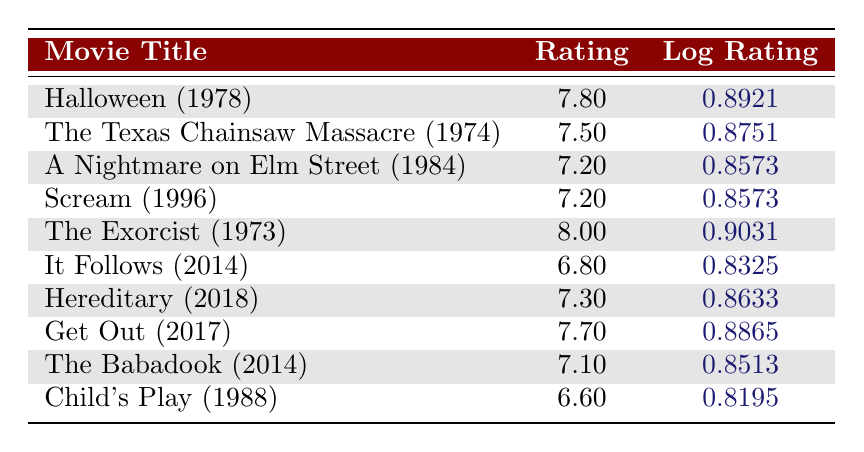What is the highest rating among the horror movies listed? The table lists the ratings, and upon inspection, the highest rating is 8.0 for "The Exorcist (1973)."
Answer: 8.0 Which horror movie has the lowest logarithmic rating in the table? Looking at the "Log Rating" column, "Child's Play (1988)" has the lowest logarithmic value of approximately 0.8195.
Answer: 0.8195 Is "Get Out (2017)" rated higher than "Hereditary (2018)"? "Get Out (2017)" has a rating of 7.7, while "Hereditary (2018)" has a rating of 7.3. Since 7.7 is greater than 7.3, "Get Out (2017)" is indeed rated higher.
Answer: Yes What is the average rating of all movies listed in the table? To find the average, add all ratings (7.8 + 7.5 + 7.2 + 7.2 + 8.0 + 6.8 + 7.3 + 7.7 + 7.1 + 6.6 = 78.0) and divide by the number of movies (10). The average rating is 78.0 / 10 = 7.8.
Answer: 7.8 Is the median rating of the horror movies above 7? First, arrange the ratings in ascending order: 6.6, 6.8, 7.1, 7.2, 7.2, 7.3, 7.5, 7.7, 7.8, 8.0. The middle two values are 7.2 and 7.3. The median is (7.2 + 7.3) / 2 = 7.25, which is below 7.
Answer: No What is the difference between the highest and lowest ratings in the dataset? The highest rating is 8.0 for "The Exorcist (1973)," and the lowest rating is 6.6 for "Child's Play (1988)." The difference is 8.0 - 6.6 = 1.4.
Answer: 1.4 How many movies have a rating above 7.5? The movies with ratings above 7.5 are "Halloween (1978)" (7.8), "The Exorcist (1973)" (8.0), and "Get Out (2017)" (7.7). Therefore, there are three movies in total.
Answer: 3 Does "A Nightmare on Elm Street (1984)" have a higher rating than "Scream (1996)"? Both movies have a rating of 7.2, so they are equal in rating. Thus, "A Nightmare on Elm Street (1984)" does not have a higher rating than "Scream (1996)."
Answer: No What is the sum of the logarithmic ratings for all the horror movies? To find the sum, we add the logarithmic ratings: 0.8921 + 0.8751 + 0.8573 + 0.8573 + 0.9031 + 0.8325 + 0.8633 + 0.8865 + 0.8513 + 0.8195 = 8.2279.
Answer: 8.2279 